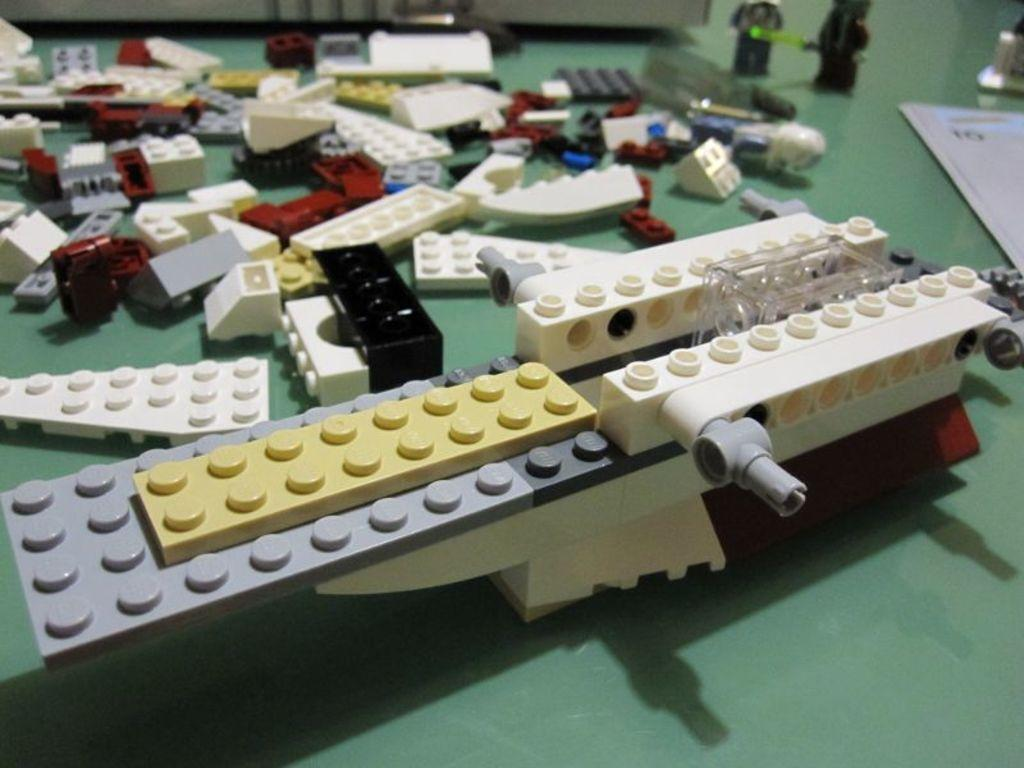What type of toy is present in the image? There are Lego bricks in the image. What else can be seen on the object in the image? There are other items on an object in the image. What type of wish can be granted by the notebook in the image? There is no notebook present in the image, so it is not possible to grant any wishes from it. 